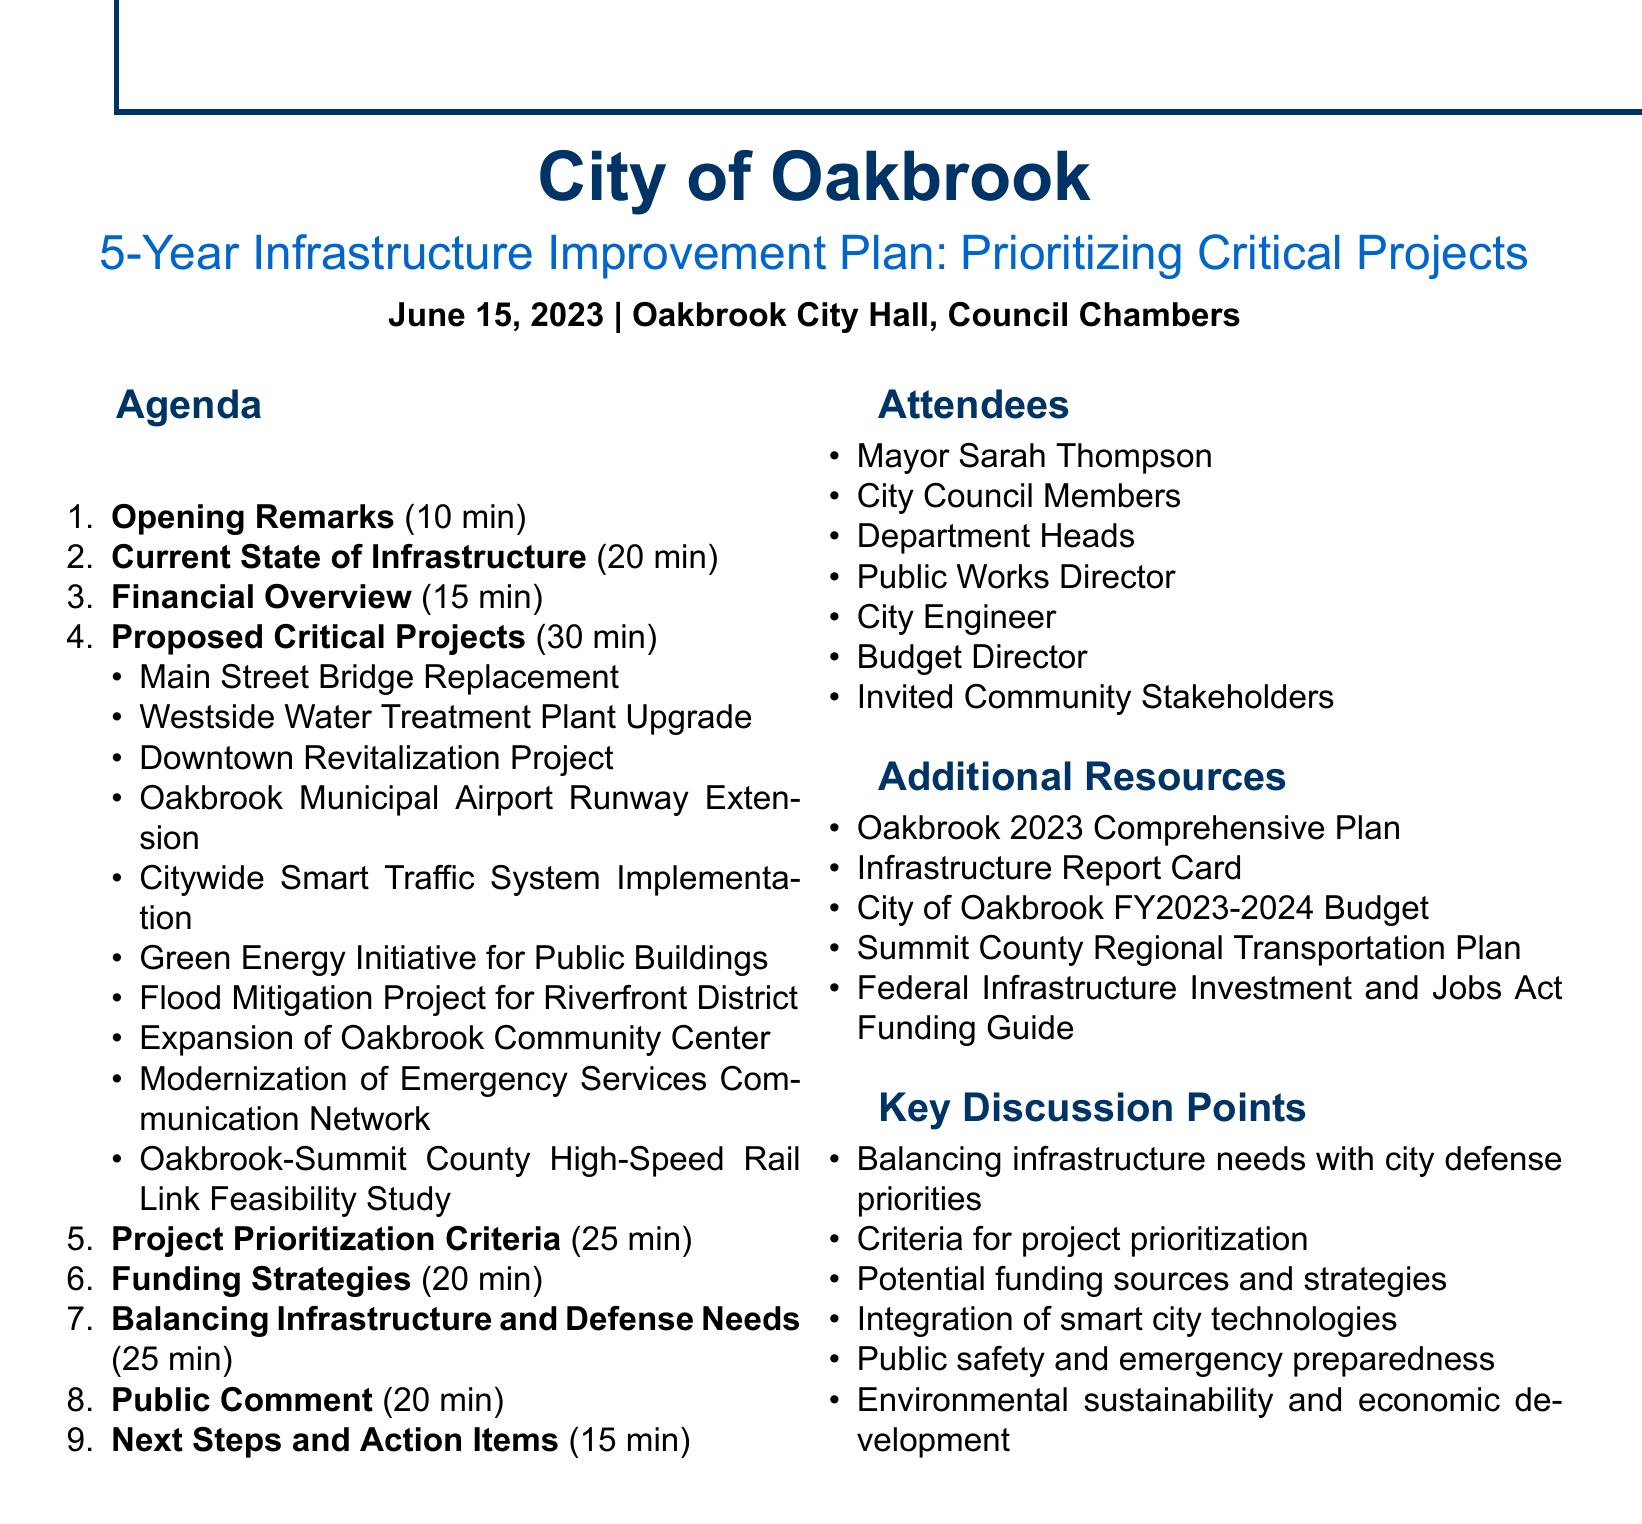What is the title of the agenda? The title is the main heading of the document and summarizes the topic.
Answer: City of Oakbrook 5-Year Infrastructure Improvement Plan: Prioritizing Critical Projects Who will present the Current State of Oakbrook's Infrastructure? This information is found within the agenda items section, specifying who is responsible for each item.
Answer: City Engineer John Martinez What is the duration of the Proposed Critical Projects presentation? The duration indicates how long this specific presentation will last, as listed in the agenda.
Answer: 30 minutes How many attendees are mentioned in the document? This is determined by counting the individuals listed under the attendees section.
Answer: 7 attendees What is one of the criteria for prioritizing projects? This requires recalling information from the criteria list in the agenda item discussing prioritization.
Answer: Public safety impact Who leads the discussion on balancing infrastructure and defense needs? The document specifies who will be responsible for leading certain discussions.
Answer: Mayor Thompson What type of funding is a potential strategy mentioned? This question looks for specific examples of funding strategies listed in the document.
Answer: Federal infrastructure grants What is one of the additional resources included? This question asks for a specific item listed under the additional resources section.
Answer: Oakbrook 2023 Comprehensive Plan What is the location of the meeting? This information provides the specific venue where the meeting will take place, as stated in the header.
Answer: Oakbrook City Hall, Council Chambers 